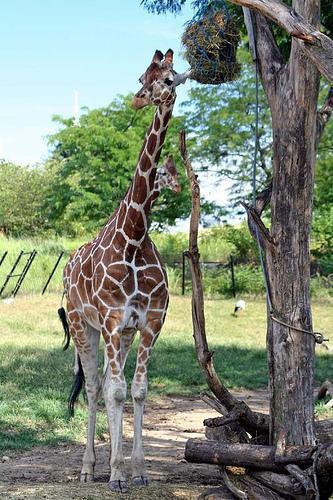How many people have on blue jeans?
Give a very brief answer. 0. 